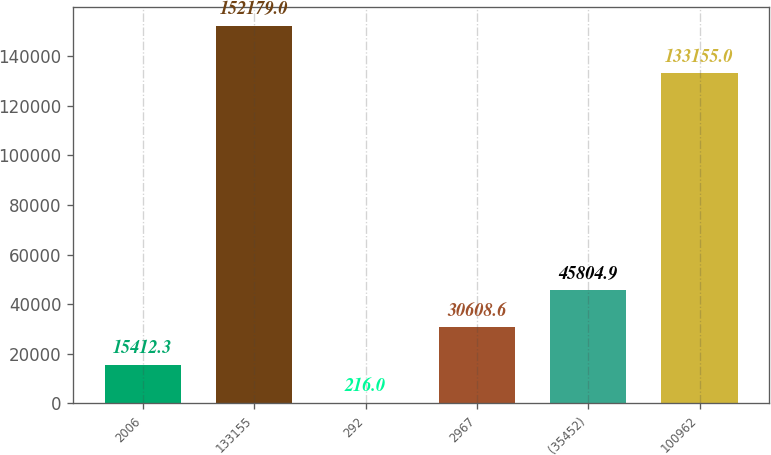Convert chart. <chart><loc_0><loc_0><loc_500><loc_500><bar_chart><fcel>2006<fcel>133155<fcel>292<fcel>2967<fcel>(35452)<fcel>100962<nl><fcel>15412.3<fcel>152179<fcel>216<fcel>30608.6<fcel>45804.9<fcel>133155<nl></chart> 